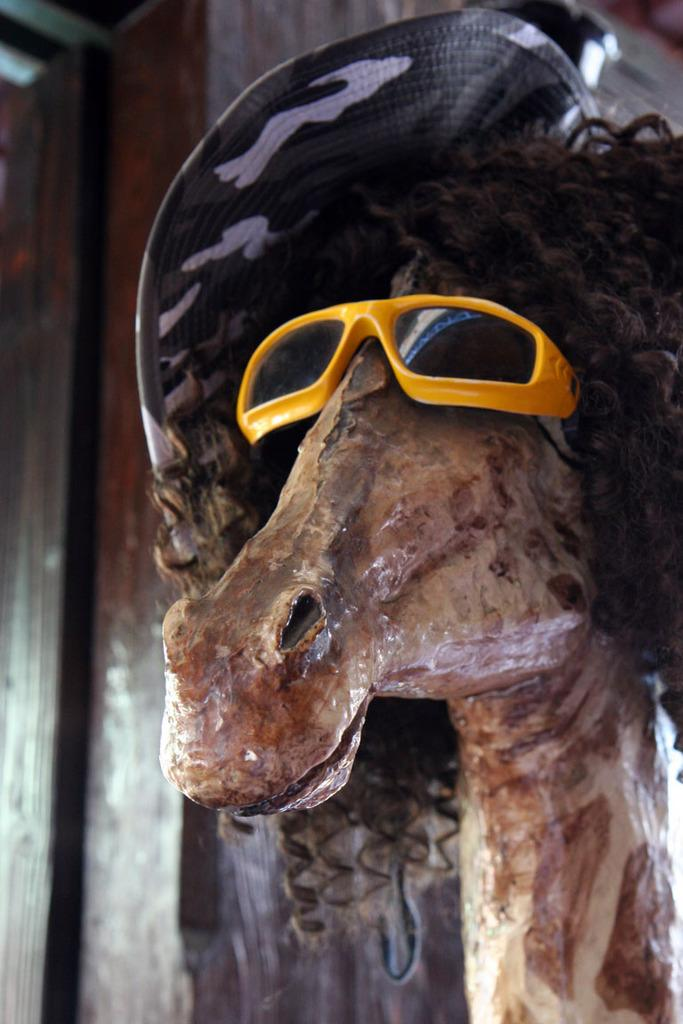What type of animal is depicted in the statue on the right side of the image? The statue is of an animal with sunglasses and hair. What additional features does the statue have? The animal in the statue is wearing sunglasses and has hair. What can be seen in the background of the image? There is a pillar in the background of the image. What type of pie is being served on the cart in the image? There is no cart or pie present in the image. What color is the pen used by the person in the image? There is no person or pen present in the image. 